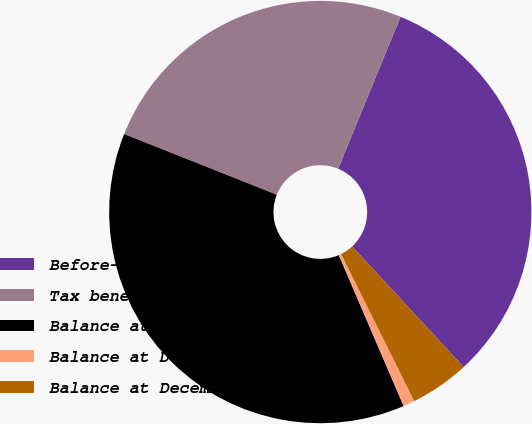Convert chart. <chart><loc_0><loc_0><loc_500><loc_500><pie_chart><fcel>Before-tax amount<fcel>Tax benefit (expense)<fcel>Balance at December 31 2004<fcel>Balance at December 31 2005<fcel>Balance at December 31 2006<nl><fcel>31.92%<fcel>25.18%<fcel>37.48%<fcel>0.88%<fcel>4.54%<nl></chart> 